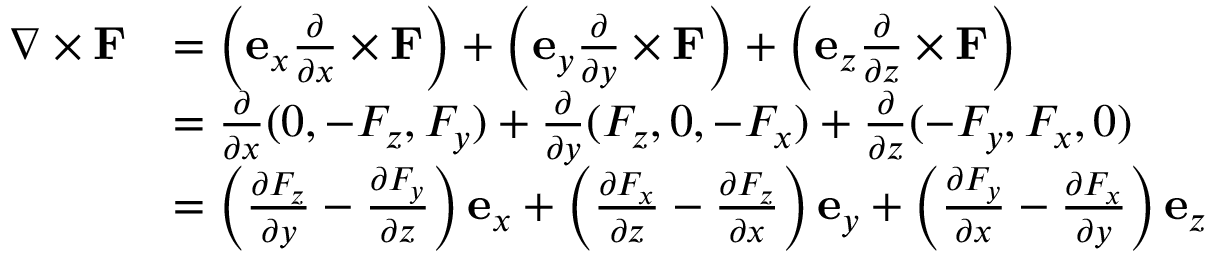Convert formula to latex. <formula><loc_0><loc_0><loc_500><loc_500>{ \begin{array} { r l } { \nabla \times F } & { = \left ( e _ { x } { \frac { \partial } { \partial x } } \times F \right ) + \left ( e _ { y } { \frac { \partial } { \partial y } } \times F \right ) + \left ( e _ { z } { \frac { \partial } { \partial z } } \times F \right ) } \\ & { = { \frac { \partial } { \partial x } } ( 0 , - F _ { z } , F _ { y } ) + { \frac { \partial } { \partial y } } ( F _ { z } , 0 , - F _ { x } ) + { \frac { \partial } { \partial z } } ( - F _ { y } , F _ { x } , 0 ) } \\ & { = \left ( { \frac { \partial F _ { z } } { \partial y } } - { \frac { \partial F _ { y } } { \partial z } } \right ) e _ { x } + \left ( { \frac { \partial F _ { x } } { \partial z } } - { \frac { \partial F _ { z } } { \partial x } } \right ) e _ { y } + \left ( { \frac { \partial F _ { y } } { \partial x } } - { \frac { \partial F _ { x } } { \partial y } } \right ) e _ { z } } \end{array} }</formula> 